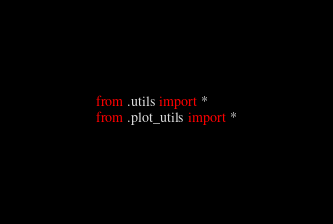<code> <loc_0><loc_0><loc_500><loc_500><_Python_>from .utils import *
from .plot_utils import *</code> 